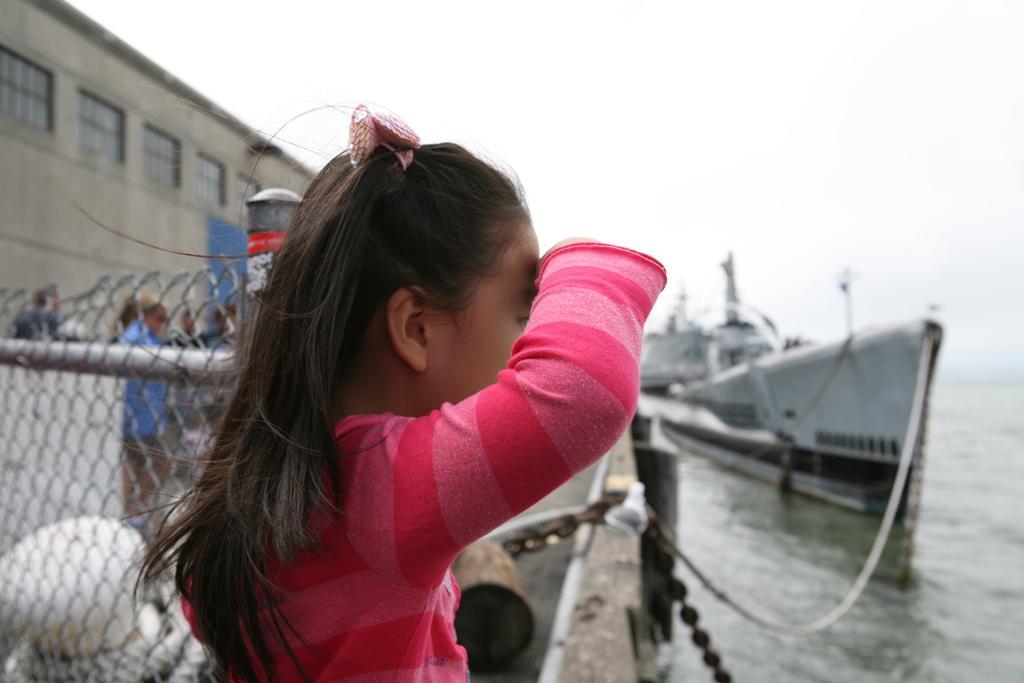Can you describe this image briefly? In this image I can see a girl in pink dress. I can also see fencing, building, water and in it I can see a ship. I can also see few people are standing over there and I can see this image is little bit blurry from background. 